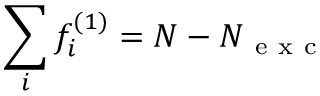Convert formula to latex. <formula><loc_0><loc_0><loc_500><loc_500>\sum _ { i } f _ { i } ^ { ( 1 ) } = N - N _ { e x c }</formula> 